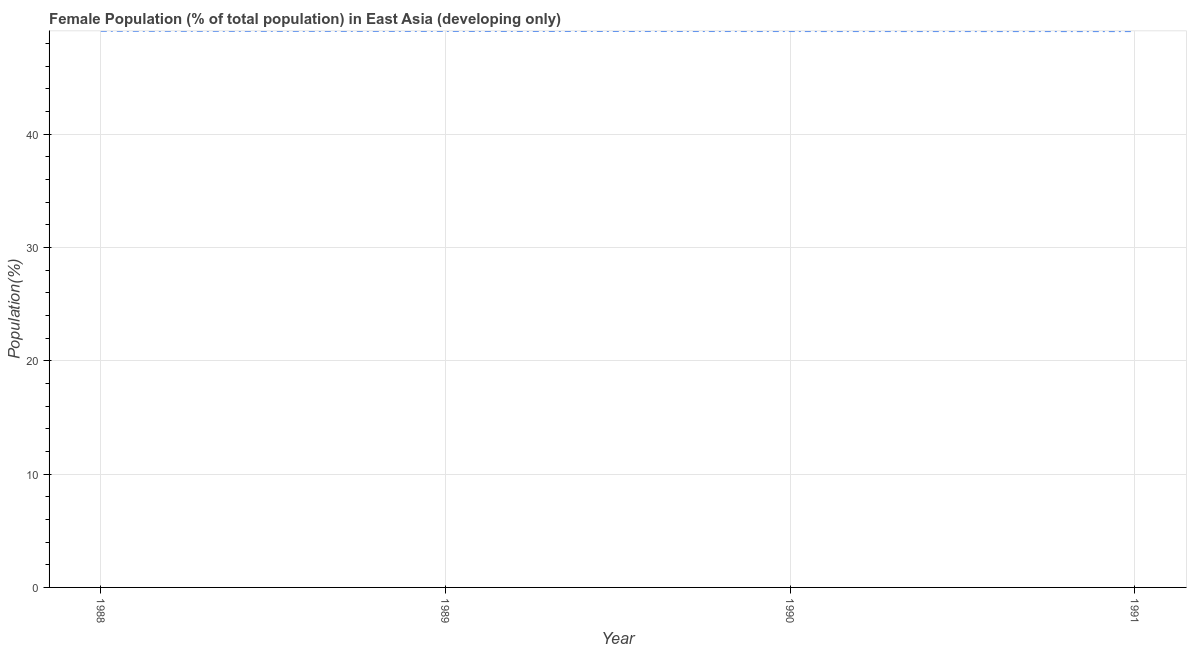What is the female population in 1989?
Offer a terse response. 49.12. Across all years, what is the maximum female population?
Make the answer very short. 49.13. Across all years, what is the minimum female population?
Keep it short and to the point. 49.11. In which year was the female population minimum?
Keep it short and to the point. 1991. What is the sum of the female population?
Keep it short and to the point. 196.48. What is the difference between the female population in 1988 and 1989?
Offer a very short reply. 0.01. What is the average female population per year?
Provide a succinct answer. 49.12. What is the median female population?
Your response must be concise. 49.12. Do a majority of the years between 1990 and 1991 (inclusive) have female population greater than 4 %?
Keep it short and to the point. Yes. What is the ratio of the female population in 1989 to that in 1991?
Offer a terse response. 1. Is the difference between the female population in 1989 and 1991 greater than the difference between any two years?
Keep it short and to the point. No. What is the difference between the highest and the second highest female population?
Provide a succinct answer. 0.01. Is the sum of the female population in 1989 and 1991 greater than the maximum female population across all years?
Your response must be concise. Yes. What is the difference between the highest and the lowest female population?
Offer a terse response. 0.02. In how many years, is the female population greater than the average female population taken over all years?
Make the answer very short. 2. Does the female population monotonically increase over the years?
Your answer should be very brief. No. What is the difference between two consecutive major ticks on the Y-axis?
Offer a terse response. 10. Are the values on the major ticks of Y-axis written in scientific E-notation?
Make the answer very short. No. Does the graph contain any zero values?
Provide a succinct answer. No. Does the graph contain grids?
Make the answer very short. Yes. What is the title of the graph?
Make the answer very short. Female Population (% of total population) in East Asia (developing only). What is the label or title of the Y-axis?
Your answer should be compact. Population(%). What is the Population(%) of 1988?
Your answer should be compact. 49.13. What is the Population(%) in 1989?
Your answer should be compact. 49.12. What is the Population(%) in 1990?
Give a very brief answer. 49.11. What is the Population(%) of 1991?
Keep it short and to the point. 49.11. What is the difference between the Population(%) in 1988 and 1989?
Offer a very short reply. 0.01. What is the difference between the Population(%) in 1988 and 1990?
Your answer should be compact. 0.02. What is the difference between the Population(%) in 1988 and 1991?
Your response must be concise. 0.02. What is the difference between the Population(%) in 1989 and 1990?
Your answer should be compact. 0.01. What is the difference between the Population(%) in 1989 and 1991?
Ensure brevity in your answer.  0.01. What is the difference between the Population(%) in 1990 and 1991?
Offer a terse response. 0.01. What is the ratio of the Population(%) in 1988 to that in 1989?
Your answer should be very brief. 1. What is the ratio of the Population(%) in 1988 to that in 1990?
Offer a terse response. 1. What is the ratio of the Population(%) in 1988 to that in 1991?
Keep it short and to the point. 1. What is the ratio of the Population(%) in 1990 to that in 1991?
Offer a very short reply. 1. 